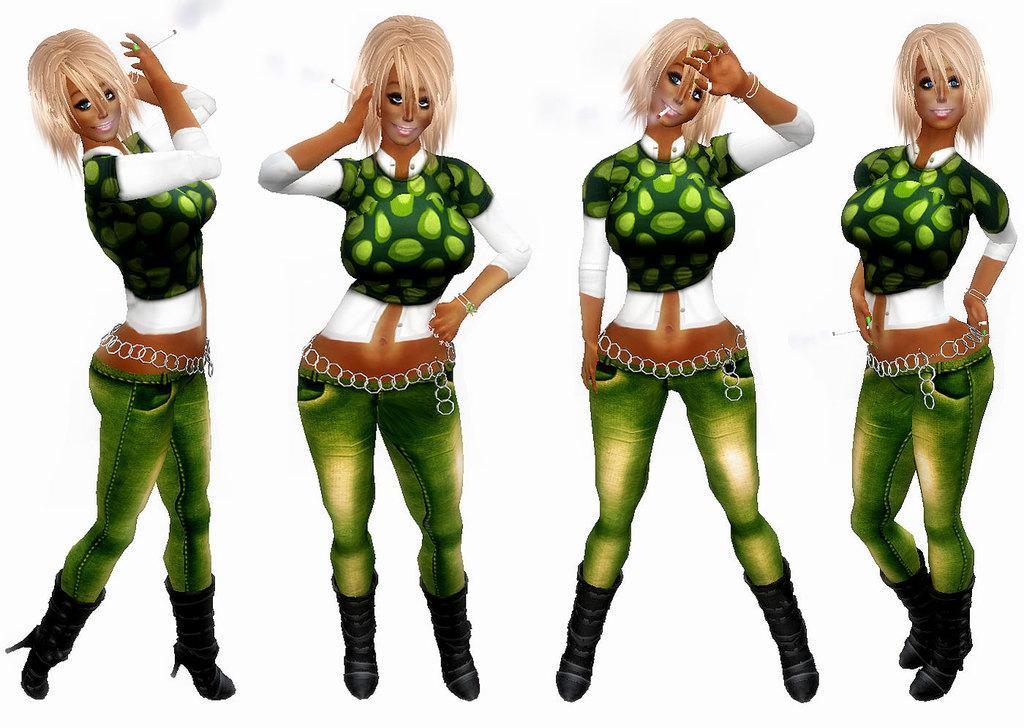Can you describe this image briefly? It is a graphical image. In the center of the image we can see a four persons are standing and they are smiling. And we can see they are in different costumes. Among them, we can see two persons are holding cigarettes and one person is smoking. And we can see the white color background. 